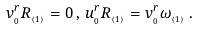<formula> <loc_0><loc_0><loc_500><loc_500>v _ { _ { 0 } } ^ { r } R _ { _ { ( 1 ) } } = 0 \, , \, u _ { _ { 0 } } ^ { r } R _ { _ { ( 1 ) } } = v _ { _ { 0 } } ^ { r } \omega _ { _ { ( 1 ) } } \, .</formula> 